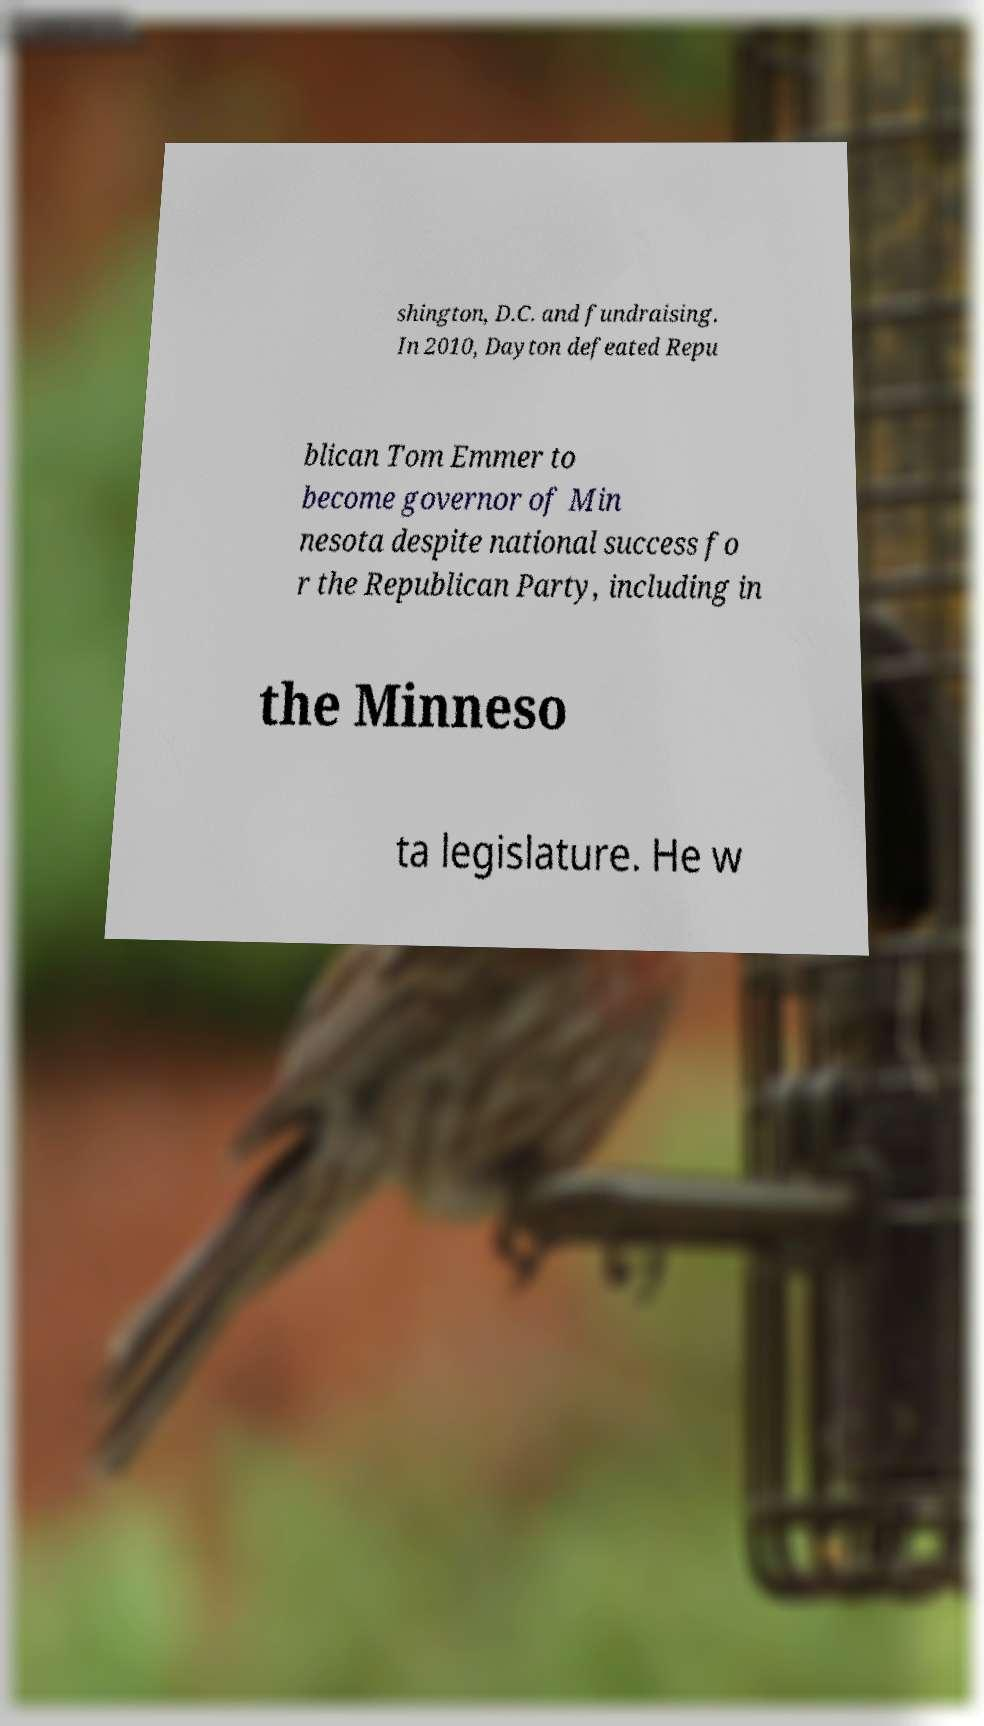Please identify and transcribe the text found in this image. shington, D.C. and fundraising. In 2010, Dayton defeated Repu blican Tom Emmer to become governor of Min nesota despite national success fo r the Republican Party, including in the Minneso ta legislature. He w 